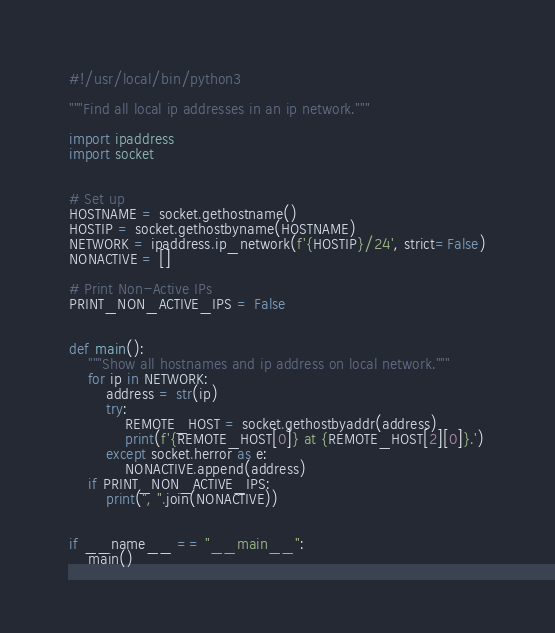<code> <loc_0><loc_0><loc_500><loc_500><_Python_>#!/usr/local/bin/python3

"""Find all local ip addresses in an ip network."""

import ipaddress
import socket


# Set up
HOSTNAME = socket.gethostname()
HOSTIP = socket.gethostbyname(HOSTNAME)
NETWORK = ipaddress.ip_network(f'{HOSTIP}/24', strict=False)
NONACTIVE = []

# Print Non-Active IPs
PRINT_NON_ACTIVE_IPS = False


def main():
    """Show all hostnames and ip address on local network."""
    for ip in NETWORK:
        address = str(ip)
        try:
            REMOTE_HOST = socket.gethostbyaddr(address)
            print(f'{REMOTE_HOST[0]} at {REMOTE_HOST[2][0]}.')
        except socket.herror as e:
            NONACTIVE.append(address)
    if PRINT_NON_ACTIVE_IPS:
        print(", ".join(NONACTIVE))


if __name__ == "__main__":
    main()
</code> 